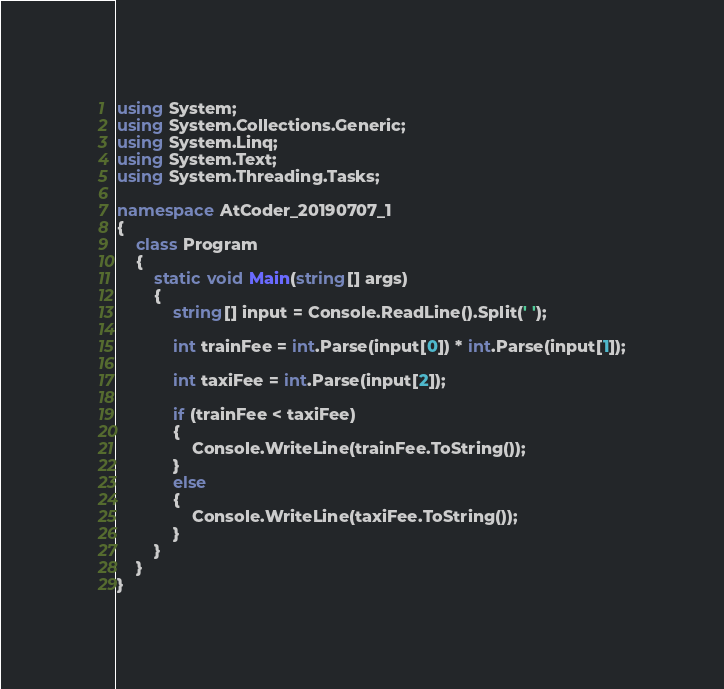Convert code to text. <code><loc_0><loc_0><loc_500><loc_500><_C#_>using System;
using System.Collections.Generic;
using System.Linq;
using System.Text;
using System.Threading.Tasks;

namespace AtCoder_20190707_1
{
    class Program
    {
        static void Main(string[] args)
        {
            string[] input = Console.ReadLine().Split(' ');

            int trainFee = int.Parse(input[0]) * int.Parse(input[1]);

            int taxiFee = int.Parse(input[2]);

            if (trainFee < taxiFee)
            {
                Console.WriteLine(trainFee.ToString());
            }
            else
            {
                Console.WriteLine(taxiFee.ToString());
            }
        }
    }
}</code> 